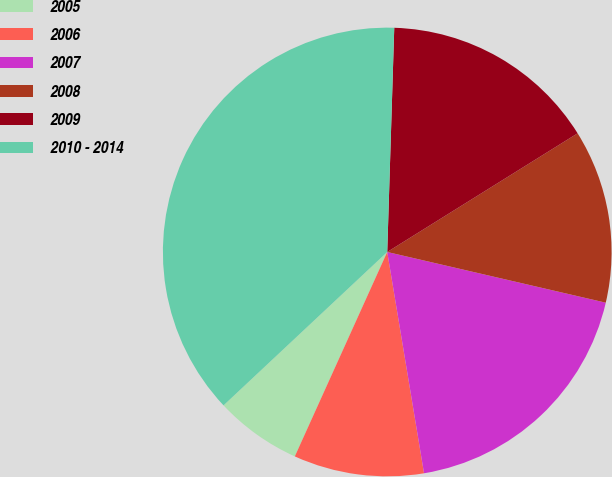Convert chart. <chart><loc_0><loc_0><loc_500><loc_500><pie_chart><fcel>2005<fcel>2006<fcel>2007<fcel>2008<fcel>2009<fcel>2010 - 2014<nl><fcel>6.26%<fcel>9.38%<fcel>18.75%<fcel>12.5%<fcel>15.63%<fcel>37.48%<nl></chart> 